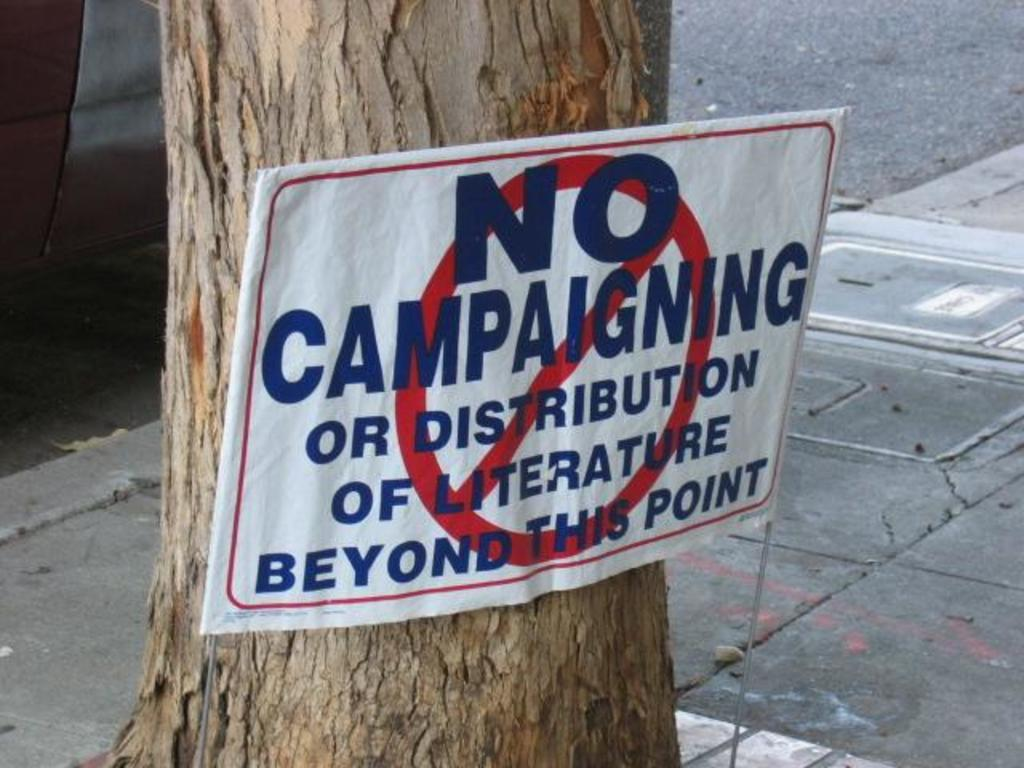What is the main subject of the picture? The main subject of the picture is a tree trunk. Is there any additional information or object related to the tree trunk? Yes, there is a caution board stuck in the tree trunk. What type of punishment is being enforced on the tree trunk in the image? There is no punishment being enforced on the tree trunk in the image; it simply has a caution board stuck in it. 